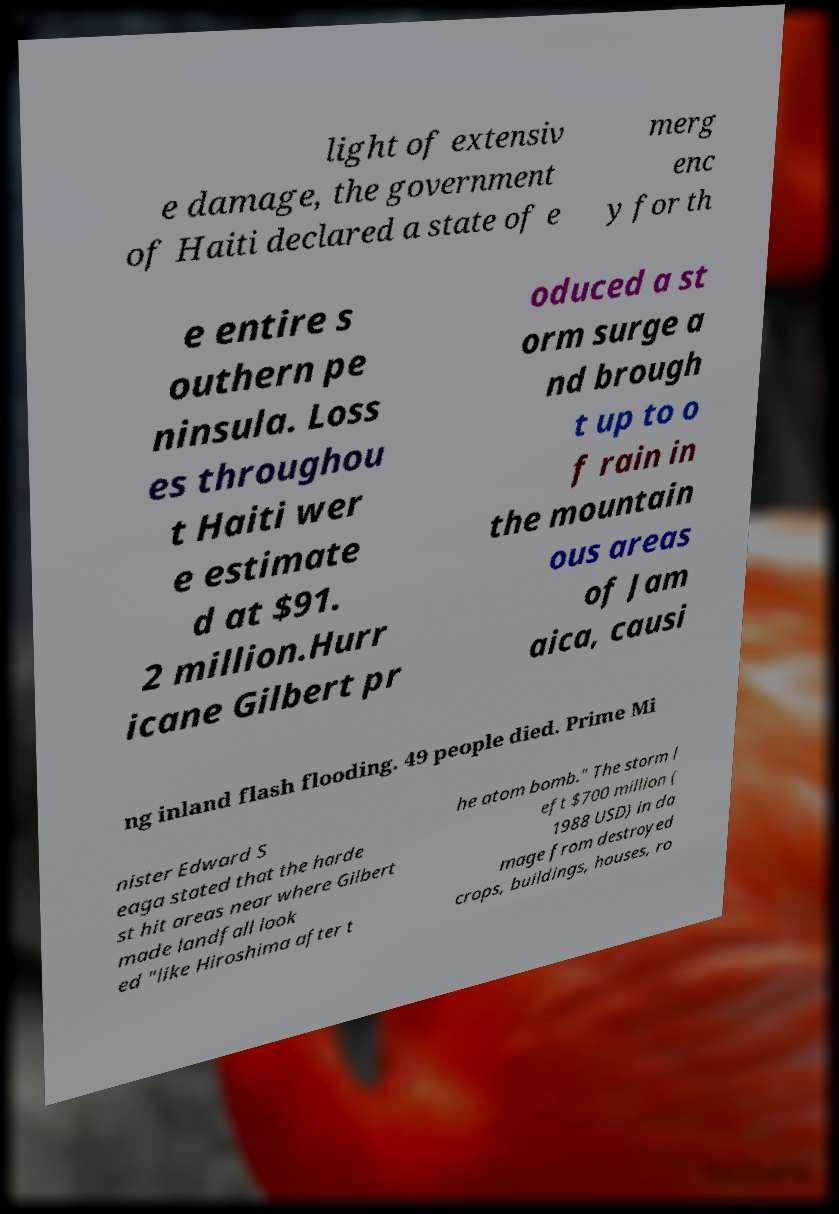Can you read and provide the text displayed in the image?This photo seems to have some interesting text. Can you extract and type it out for me? light of extensiv e damage, the government of Haiti declared a state of e merg enc y for th e entire s outhern pe ninsula. Loss es throughou t Haiti wer e estimate d at $91. 2 million.Hurr icane Gilbert pr oduced a st orm surge a nd brough t up to o f rain in the mountain ous areas of Jam aica, causi ng inland flash flooding. 49 people died. Prime Mi nister Edward S eaga stated that the harde st hit areas near where Gilbert made landfall look ed "like Hiroshima after t he atom bomb." The storm l eft $700 million ( 1988 USD) in da mage from destroyed crops, buildings, houses, ro 